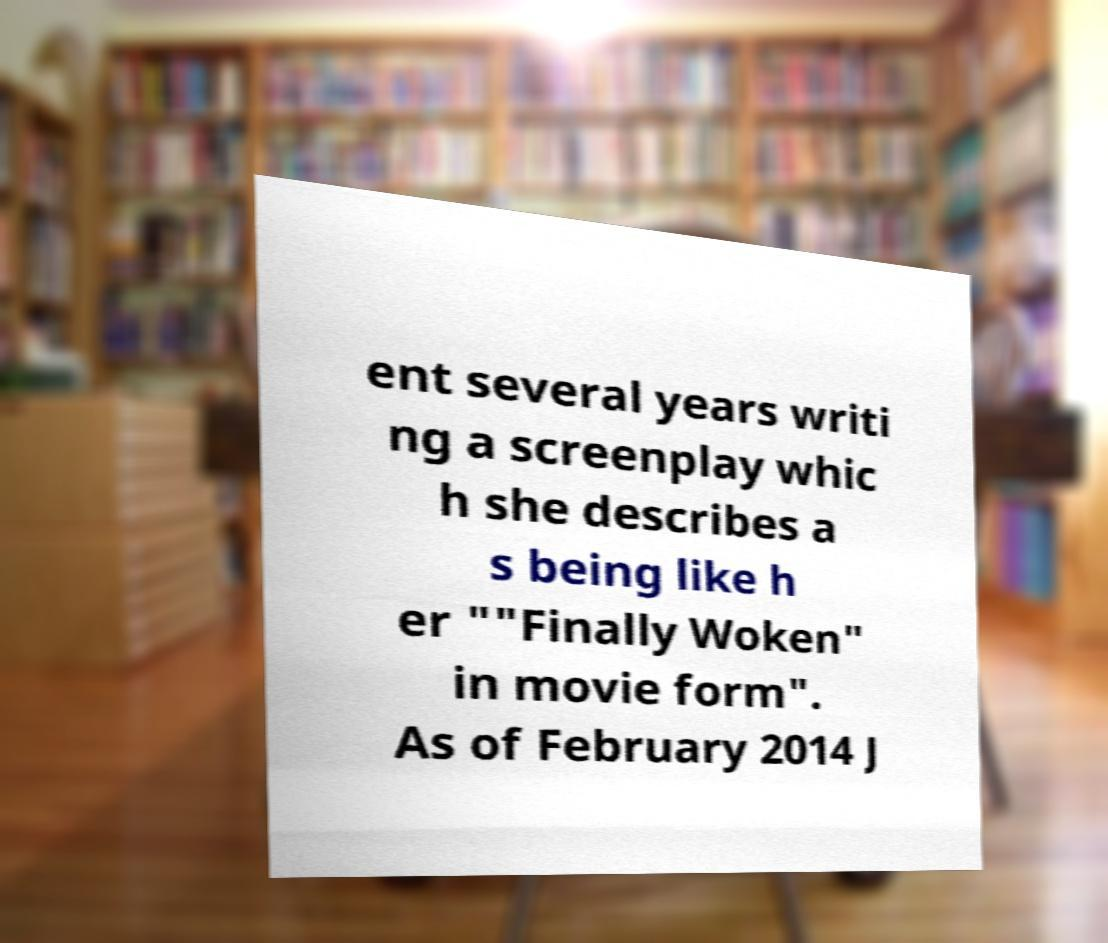What messages or text are displayed in this image? I need them in a readable, typed format. ent several years writi ng a screenplay whic h she describes a s being like h er ""Finally Woken" in movie form". As of February 2014 J 